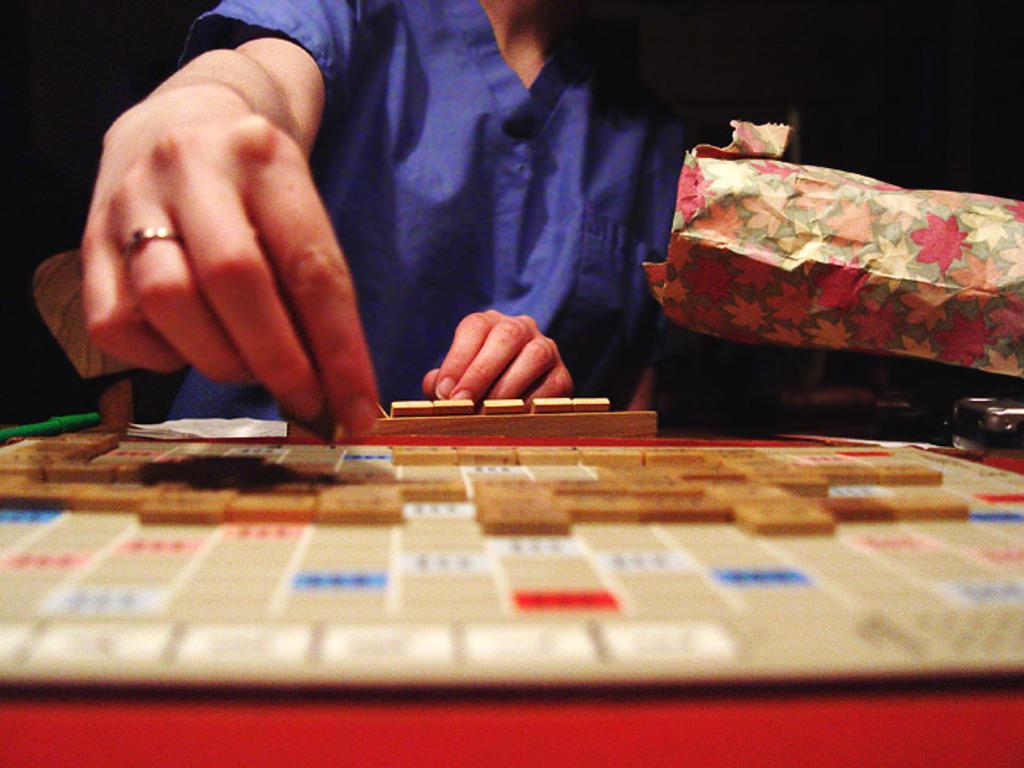Can you describe this image briefly? In the image we can see there is a word building board kept on the table, there is a person standing and she is holding a grid. 